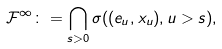Convert formula to latex. <formula><loc_0><loc_0><loc_500><loc_500>\mathcal { F } ^ { \infty } \colon = \bigcap _ { s > 0 } \sigma ( ( e _ { u } , x _ { u } ) , u > s ) ,</formula> 